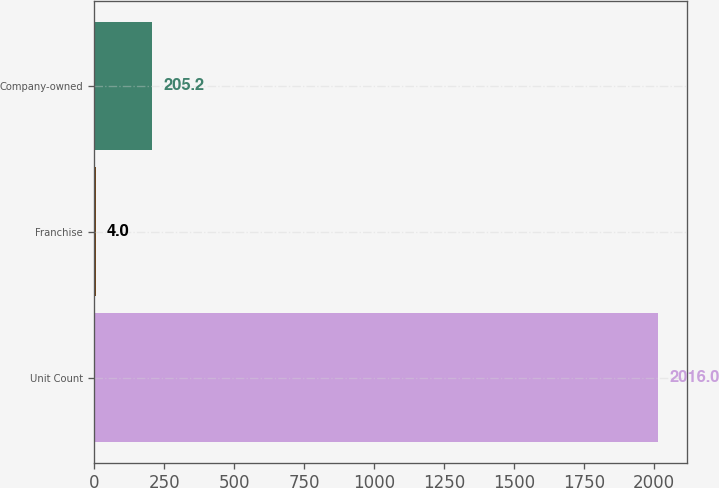Convert chart to OTSL. <chart><loc_0><loc_0><loc_500><loc_500><bar_chart><fcel>Unit Count<fcel>Franchise<fcel>Company-owned<nl><fcel>2016<fcel>4<fcel>205.2<nl></chart> 